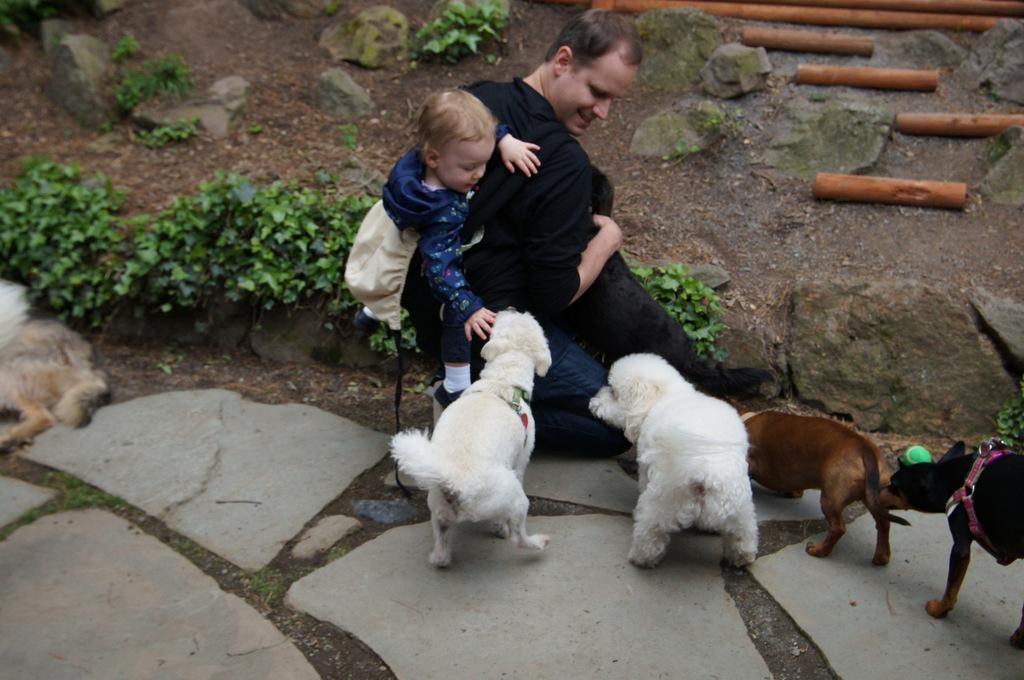How many people are present in the image? There are two people in the image. What is on the ground with the people in the image? There are dogs on the ground in the image. What can be seen in the background of the image? There are plants, wooden objects, and stones in the background of the image. What type of knee can be seen supporting the minister in the image? There is no minister or knee present in the image. What type of branch is being used as a prop in the image? There is no branch or prop being used in the image. 